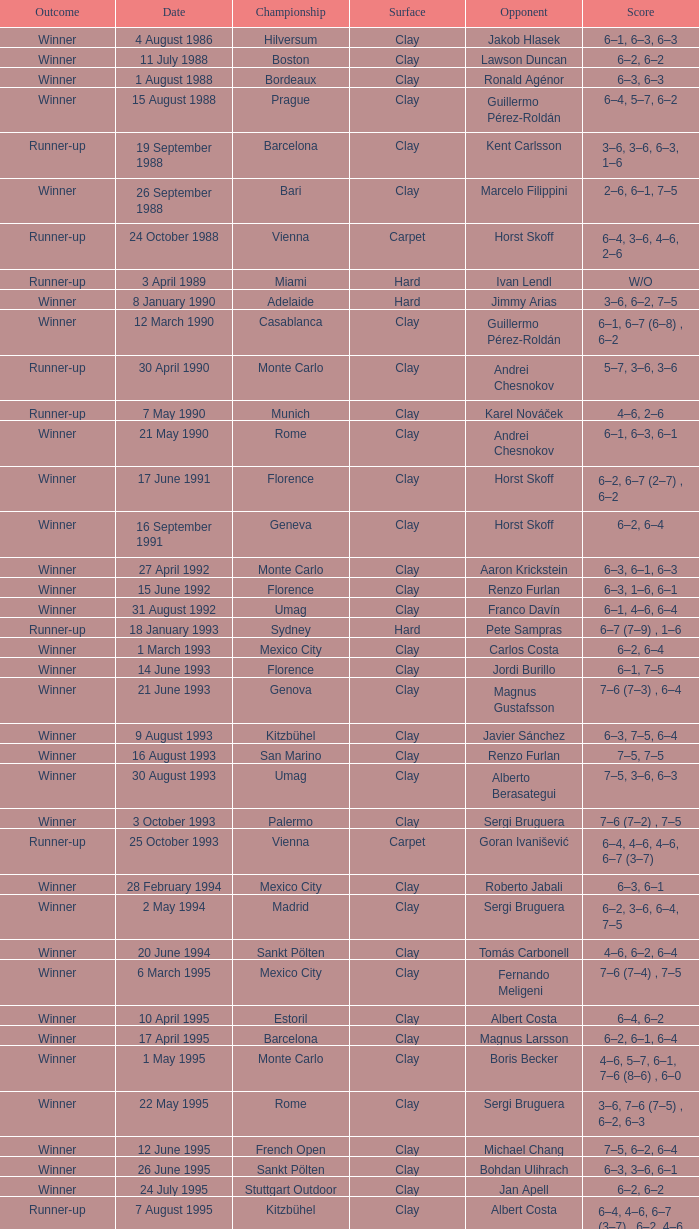What is the score when the outcome is winner against yevgeny kafelnikov? 6–2, 6–2, 6–4. 